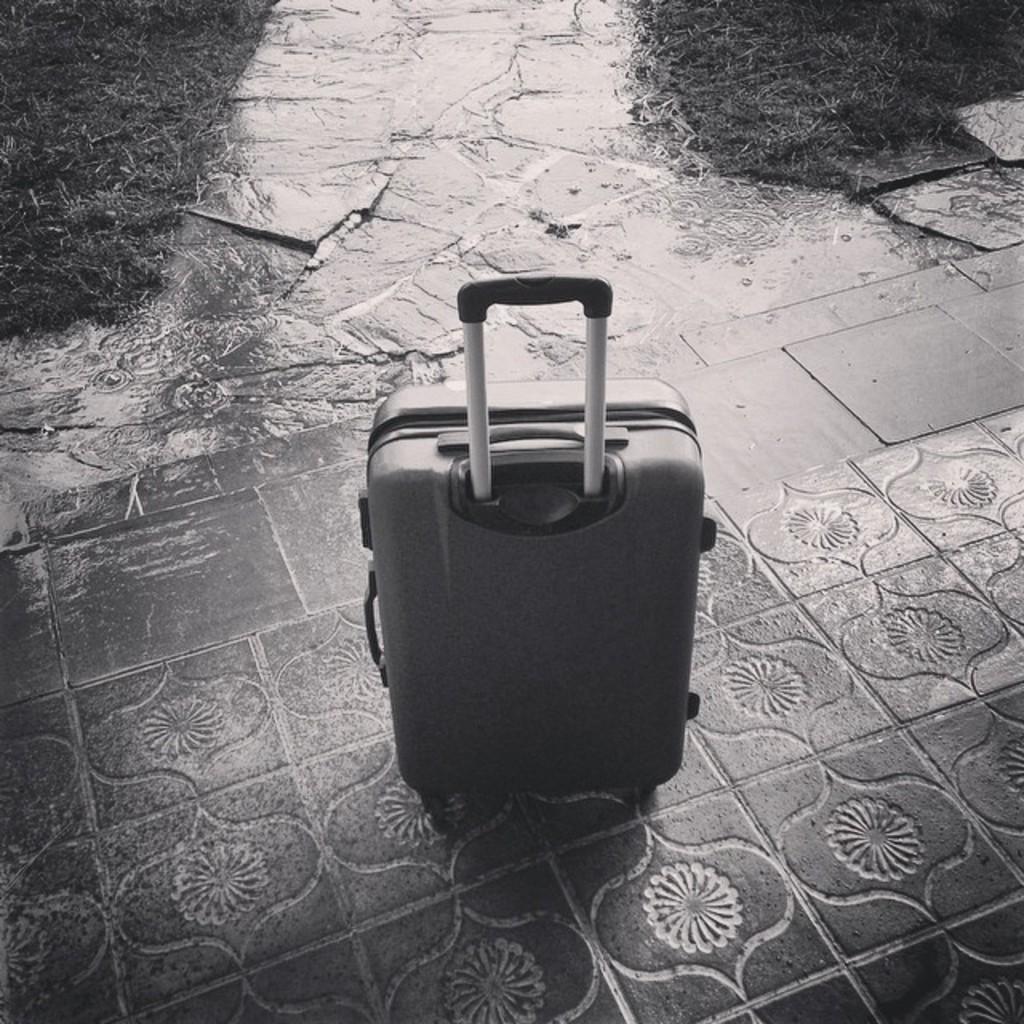Could you give a brief overview of what you see in this image? There is a luggage bag on the floor. And to the right top corner we can see a grass. 